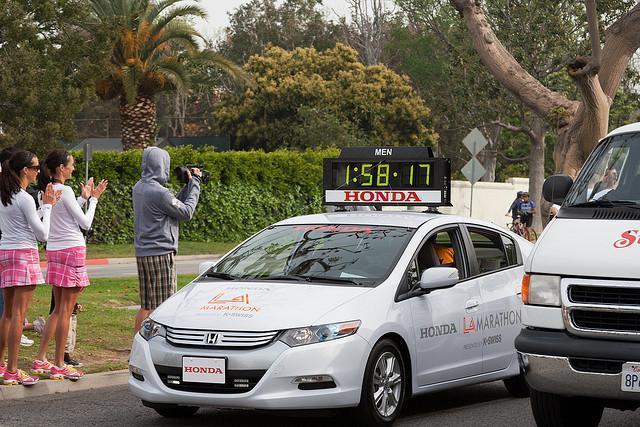How many motorcycles are in the picture?
Give a very brief answer. 0. How many people are there?
Give a very brief answer. 3. 